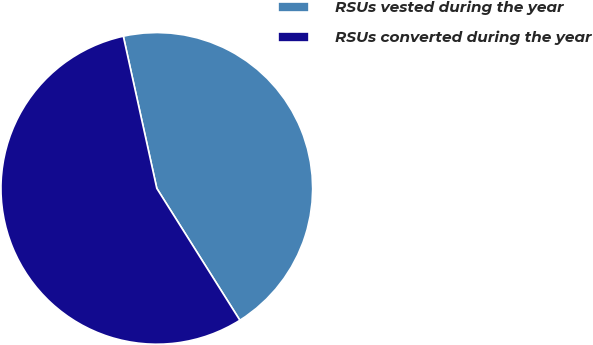Convert chart. <chart><loc_0><loc_0><loc_500><loc_500><pie_chart><fcel>RSUs vested during the year<fcel>RSUs converted during the year<nl><fcel>44.5%<fcel>55.5%<nl></chart> 